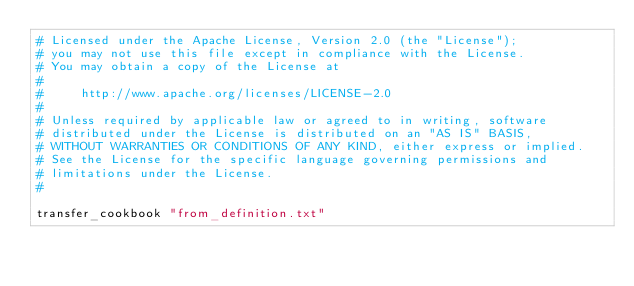<code> <loc_0><loc_0><loc_500><loc_500><_Ruby_># Licensed under the Apache License, Version 2.0 (the "License");
# you may not use this file except in compliance with the License.
# You may obtain a copy of the License at
# 
#     http://www.apache.org/licenses/LICENSE-2.0
# 
# Unless required by applicable law or agreed to in writing, software
# distributed under the License is distributed on an "AS IS" BASIS,
# WITHOUT WARRANTIES OR CONDITIONS OF ANY KIND, either express or implied.
# See the License for the specific language governing permissions and
# limitations under the License.
#

transfer_cookbook "from_definition.txt" 
</code> 